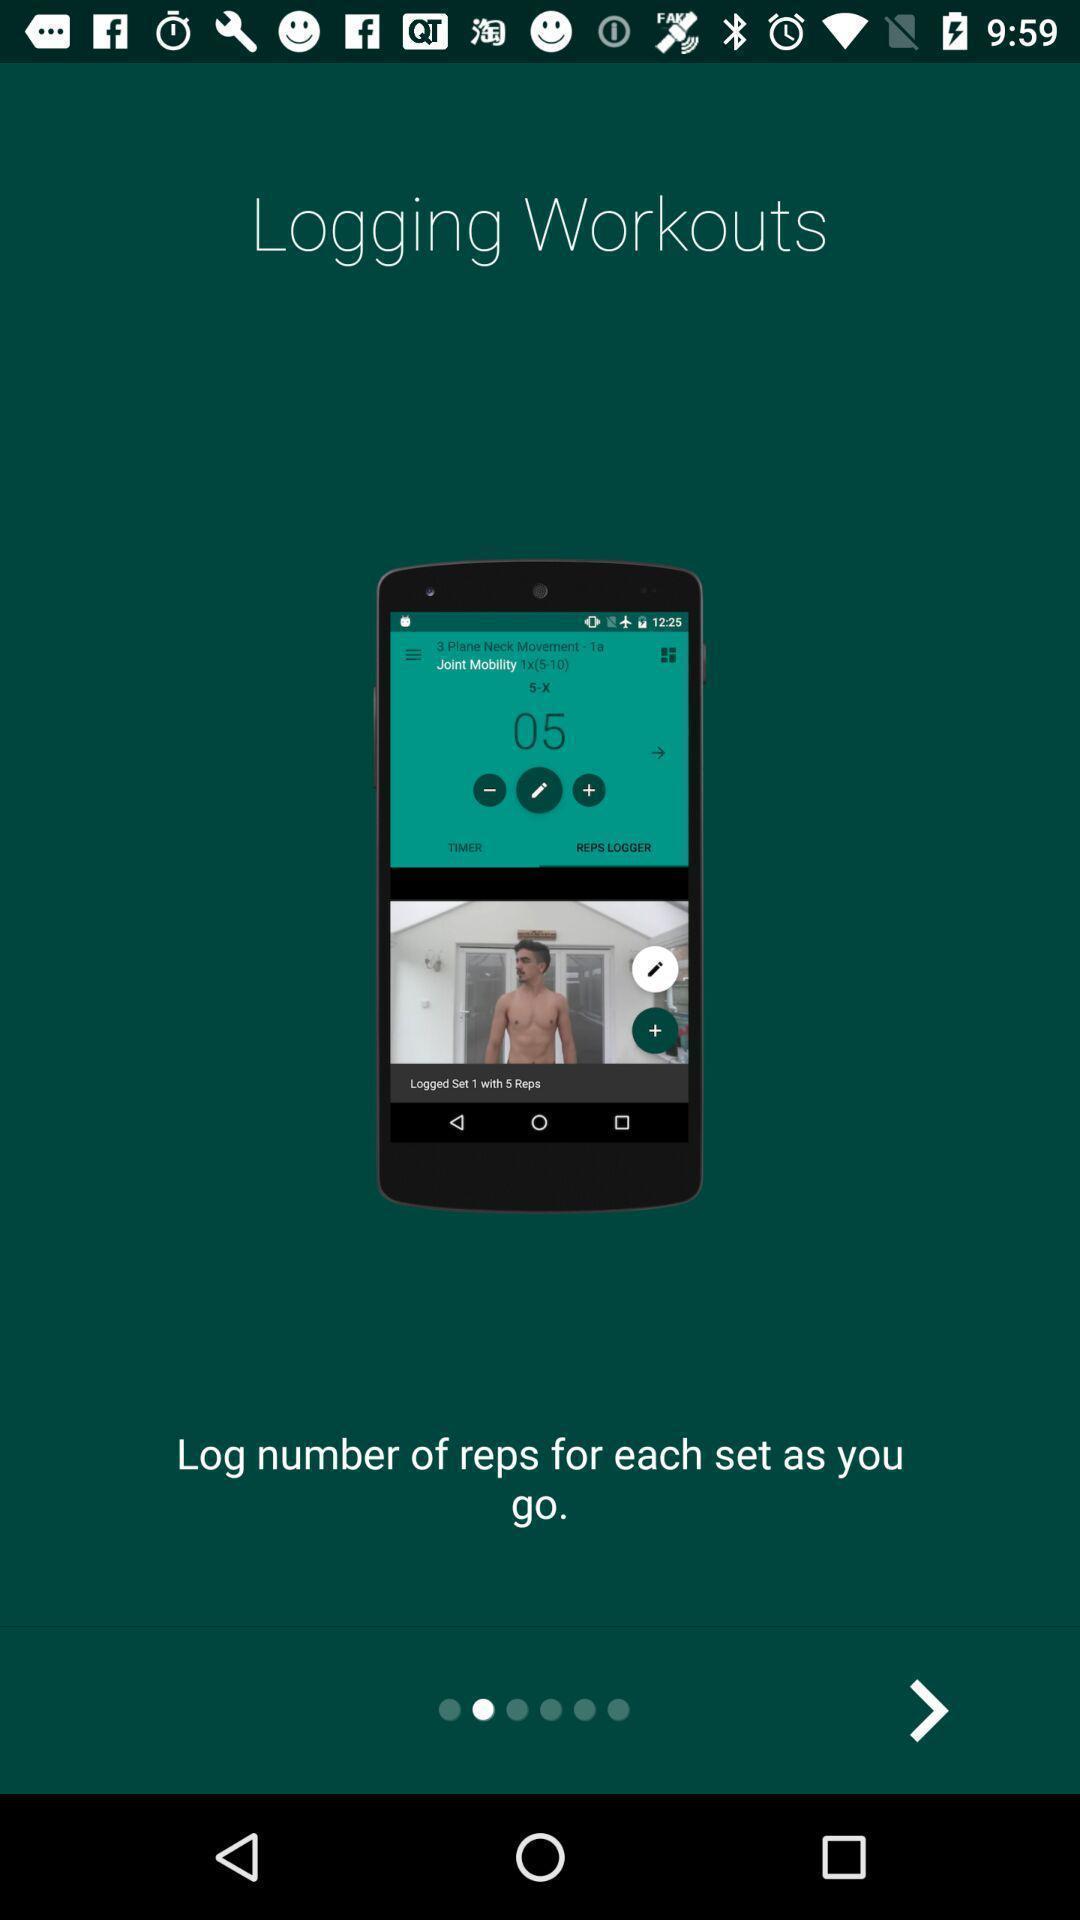Tell me about the visual elements in this screen capture. Welcome page. 